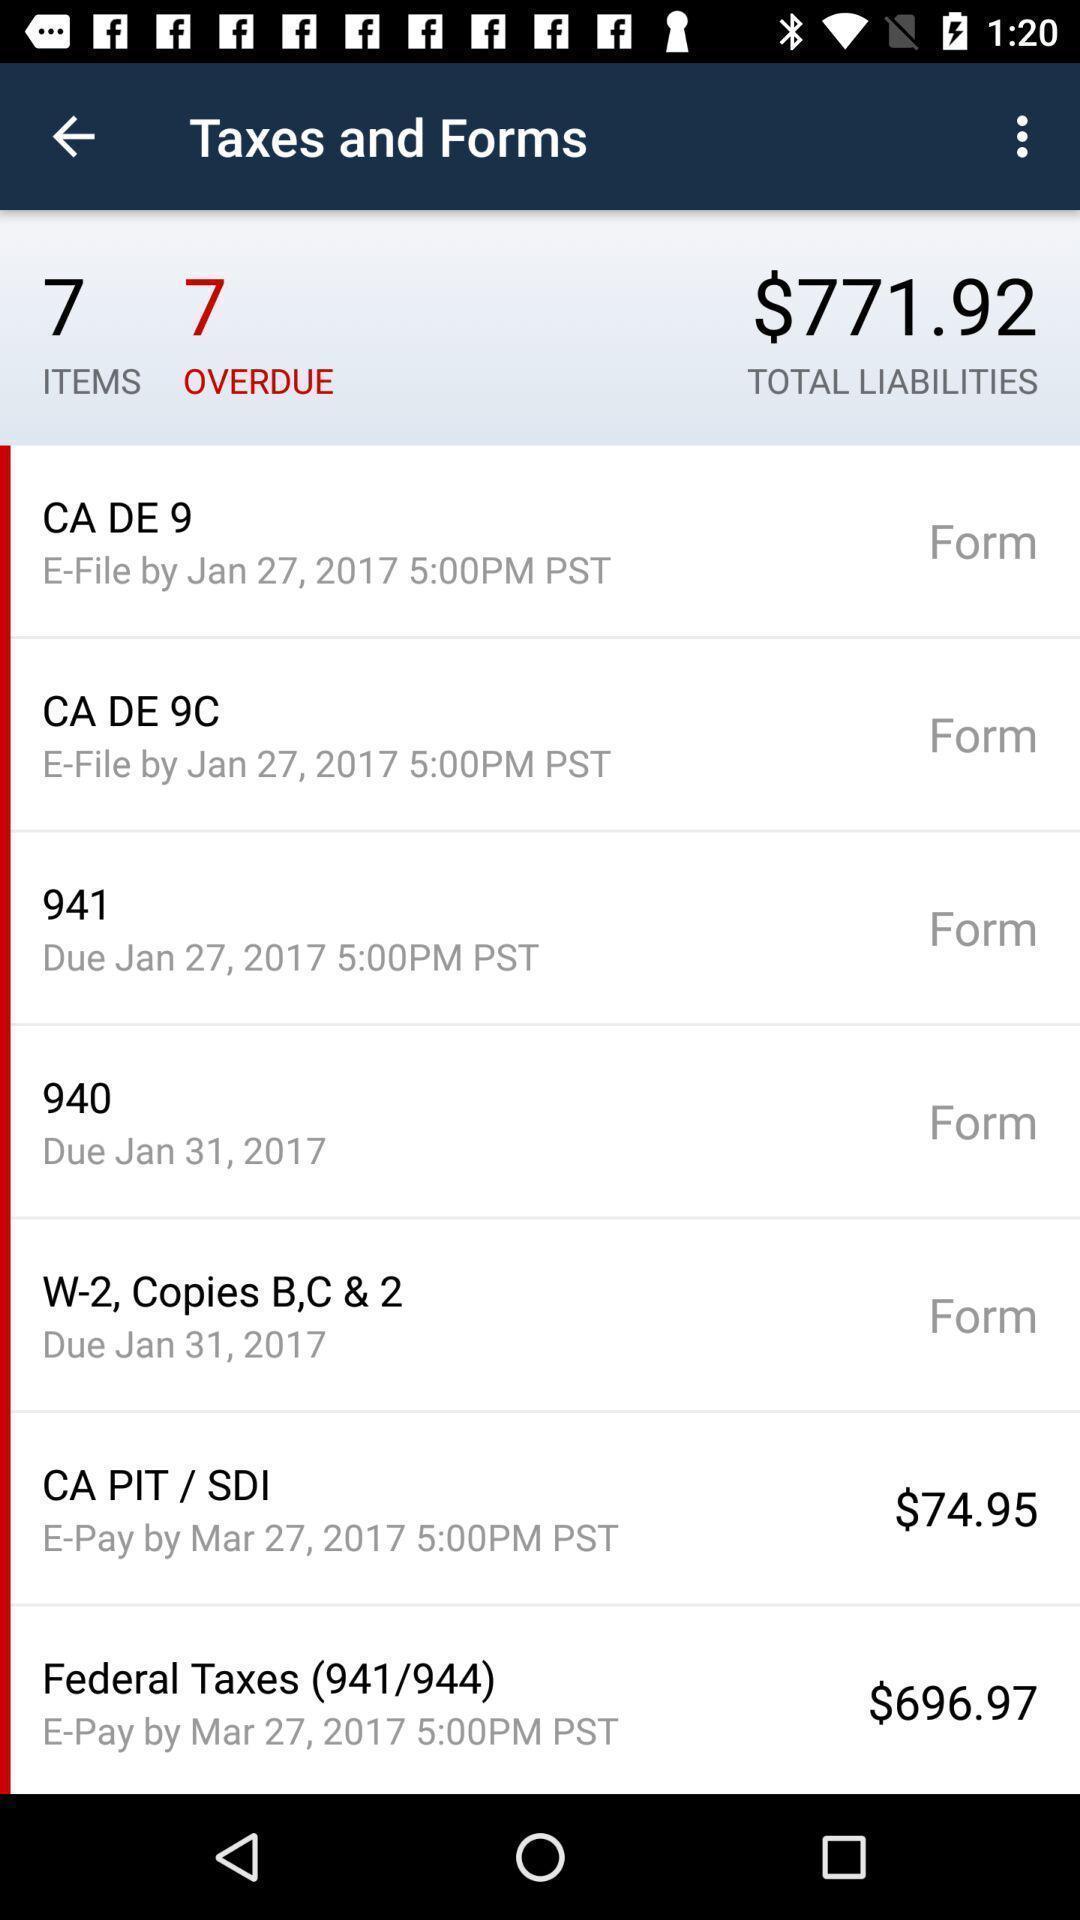Provide a textual representation of this image. Taxes and forms screen with some information in accounts app. 